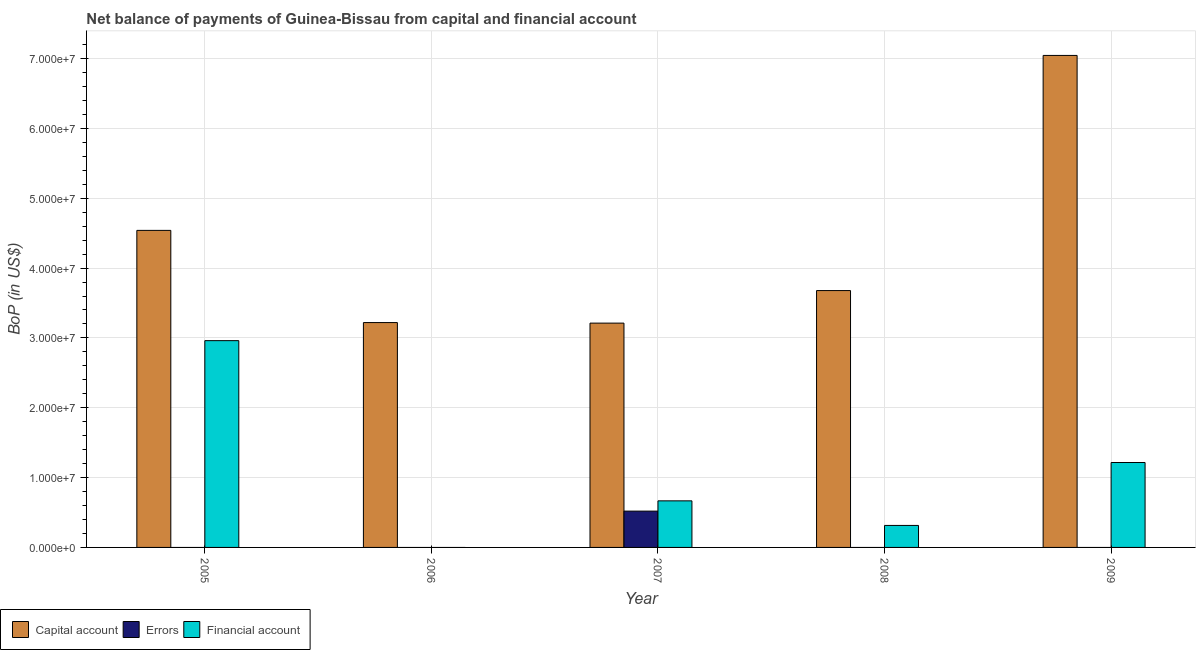How many different coloured bars are there?
Ensure brevity in your answer.  3. How many bars are there on the 1st tick from the right?
Provide a short and direct response. 2. In how many cases, is the number of bars for a given year not equal to the number of legend labels?
Keep it short and to the point. 4. What is the amount of financial account in 2005?
Your answer should be very brief. 2.96e+07. Across all years, what is the maximum amount of financial account?
Your answer should be compact. 2.96e+07. Across all years, what is the minimum amount of errors?
Provide a succinct answer. 0. In which year was the amount of errors maximum?
Your answer should be very brief. 2007. What is the total amount of financial account in the graph?
Your answer should be very brief. 5.16e+07. What is the difference between the amount of net capital account in 2006 and that in 2008?
Give a very brief answer. -4.58e+06. What is the difference between the amount of financial account in 2006 and the amount of net capital account in 2009?
Ensure brevity in your answer.  -1.22e+07. What is the average amount of net capital account per year?
Provide a succinct answer. 4.34e+07. In how many years, is the amount of net capital account greater than 24000000 US$?
Keep it short and to the point. 5. What is the ratio of the amount of financial account in 2005 to that in 2009?
Keep it short and to the point. 2.43. What is the difference between the highest and the second highest amount of net capital account?
Keep it short and to the point. 2.51e+07. What is the difference between the highest and the lowest amount of errors?
Ensure brevity in your answer.  5.20e+06. Is the sum of the amount of financial account in 2005 and 2009 greater than the maximum amount of errors across all years?
Provide a succinct answer. Yes. How many years are there in the graph?
Keep it short and to the point. 5. What is the difference between two consecutive major ticks on the Y-axis?
Provide a short and direct response. 1.00e+07. Where does the legend appear in the graph?
Your answer should be very brief. Bottom left. How are the legend labels stacked?
Your answer should be very brief. Horizontal. What is the title of the graph?
Your response must be concise. Net balance of payments of Guinea-Bissau from capital and financial account. What is the label or title of the Y-axis?
Provide a succinct answer. BoP (in US$). What is the BoP (in US$) in Capital account in 2005?
Provide a short and direct response. 4.54e+07. What is the BoP (in US$) of Errors in 2005?
Your answer should be very brief. 0. What is the BoP (in US$) in Financial account in 2005?
Provide a succinct answer. 2.96e+07. What is the BoP (in US$) of Capital account in 2006?
Offer a terse response. 3.22e+07. What is the BoP (in US$) in Errors in 2006?
Offer a terse response. 0. What is the BoP (in US$) in Capital account in 2007?
Ensure brevity in your answer.  3.21e+07. What is the BoP (in US$) of Errors in 2007?
Offer a terse response. 5.20e+06. What is the BoP (in US$) of Financial account in 2007?
Your answer should be compact. 6.67e+06. What is the BoP (in US$) of Capital account in 2008?
Provide a short and direct response. 3.68e+07. What is the BoP (in US$) in Financial account in 2008?
Your response must be concise. 3.15e+06. What is the BoP (in US$) of Capital account in 2009?
Provide a short and direct response. 7.05e+07. What is the BoP (in US$) in Financial account in 2009?
Offer a very short reply. 1.22e+07. Across all years, what is the maximum BoP (in US$) of Capital account?
Offer a very short reply. 7.05e+07. Across all years, what is the maximum BoP (in US$) in Errors?
Your answer should be very brief. 5.20e+06. Across all years, what is the maximum BoP (in US$) of Financial account?
Your answer should be very brief. 2.96e+07. Across all years, what is the minimum BoP (in US$) in Capital account?
Your answer should be very brief. 3.21e+07. Across all years, what is the minimum BoP (in US$) in Financial account?
Give a very brief answer. 0. What is the total BoP (in US$) in Capital account in the graph?
Keep it short and to the point. 2.17e+08. What is the total BoP (in US$) of Errors in the graph?
Your response must be concise. 5.20e+06. What is the total BoP (in US$) of Financial account in the graph?
Provide a succinct answer. 5.16e+07. What is the difference between the BoP (in US$) of Capital account in 2005 and that in 2006?
Your answer should be compact. 1.32e+07. What is the difference between the BoP (in US$) in Capital account in 2005 and that in 2007?
Your answer should be compact. 1.33e+07. What is the difference between the BoP (in US$) of Financial account in 2005 and that in 2007?
Give a very brief answer. 2.29e+07. What is the difference between the BoP (in US$) of Capital account in 2005 and that in 2008?
Provide a short and direct response. 8.62e+06. What is the difference between the BoP (in US$) in Financial account in 2005 and that in 2008?
Provide a short and direct response. 2.65e+07. What is the difference between the BoP (in US$) of Capital account in 2005 and that in 2009?
Make the answer very short. -2.51e+07. What is the difference between the BoP (in US$) in Financial account in 2005 and that in 2009?
Ensure brevity in your answer.  1.74e+07. What is the difference between the BoP (in US$) of Capital account in 2006 and that in 2007?
Your response must be concise. 7.78e+04. What is the difference between the BoP (in US$) of Capital account in 2006 and that in 2008?
Your answer should be compact. -4.58e+06. What is the difference between the BoP (in US$) of Capital account in 2006 and that in 2009?
Your answer should be compact. -3.83e+07. What is the difference between the BoP (in US$) of Capital account in 2007 and that in 2008?
Your response must be concise. -4.66e+06. What is the difference between the BoP (in US$) in Financial account in 2007 and that in 2008?
Offer a terse response. 3.52e+06. What is the difference between the BoP (in US$) in Capital account in 2007 and that in 2009?
Keep it short and to the point. -3.83e+07. What is the difference between the BoP (in US$) of Financial account in 2007 and that in 2009?
Make the answer very short. -5.49e+06. What is the difference between the BoP (in US$) in Capital account in 2008 and that in 2009?
Offer a very short reply. -3.37e+07. What is the difference between the BoP (in US$) in Financial account in 2008 and that in 2009?
Ensure brevity in your answer.  -9.01e+06. What is the difference between the BoP (in US$) in Capital account in 2005 and the BoP (in US$) in Errors in 2007?
Offer a terse response. 4.02e+07. What is the difference between the BoP (in US$) of Capital account in 2005 and the BoP (in US$) of Financial account in 2007?
Keep it short and to the point. 3.87e+07. What is the difference between the BoP (in US$) of Capital account in 2005 and the BoP (in US$) of Financial account in 2008?
Offer a very short reply. 4.22e+07. What is the difference between the BoP (in US$) in Capital account in 2005 and the BoP (in US$) in Financial account in 2009?
Your answer should be very brief. 3.32e+07. What is the difference between the BoP (in US$) in Capital account in 2006 and the BoP (in US$) in Errors in 2007?
Your answer should be very brief. 2.70e+07. What is the difference between the BoP (in US$) of Capital account in 2006 and the BoP (in US$) of Financial account in 2007?
Your response must be concise. 2.55e+07. What is the difference between the BoP (in US$) of Capital account in 2006 and the BoP (in US$) of Financial account in 2008?
Your answer should be very brief. 2.90e+07. What is the difference between the BoP (in US$) of Capital account in 2006 and the BoP (in US$) of Financial account in 2009?
Ensure brevity in your answer.  2.00e+07. What is the difference between the BoP (in US$) in Capital account in 2007 and the BoP (in US$) in Financial account in 2008?
Your answer should be compact. 2.90e+07. What is the difference between the BoP (in US$) in Errors in 2007 and the BoP (in US$) in Financial account in 2008?
Offer a terse response. 2.05e+06. What is the difference between the BoP (in US$) of Capital account in 2007 and the BoP (in US$) of Financial account in 2009?
Give a very brief answer. 2.00e+07. What is the difference between the BoP (in US$) in Errors in 2007 and the BoP (in US$) in Financial account in 2009?
Keep it short and to the point. -6.96e+06. What is the difference between the BoP (in US$) of Capital account in 2008 and the BoP (in US$) of Financial account in 2009?
Keep it short and to the point. 2.46e+07. What is the average BoP (in US$) in Capital account per year?
Ensure brevity in your answer.  4.34e+07. What is the average BoP (in US$) in Errors per year?
Your answer should be very brief. 1.04e+06. What is the average BoP (in US$) of Financial account per year?
Offer a terse response. 1.03e+07. In the year 2005, what is the difference between the BoP (in US$) of Capital account and BoP (in US$) of Financial account?
Give a very brief answer. 1.58e+07. In the year 2007, what is the difference between the BoP (in US$) of Capital account and BoP (in US$) of Errors?
Your response must be concise. 2.69e+07. In the year 2007, what is the difference between the BoP (in US$) in Capital account and BoP (in US$) in Financial account?
Your response must be concise. 2.55e+07. In the year 2007, what is the difference between the BoP (in US$) of Errors and BoP (in US$) of Financial account?
Provide a succinct answer. -1.47e+06. In the year 2008, what is the difference between the BoP (in US$) in Capital account and BoP (in US$) in Financial account?
Keep it short and to the point. 3.36e+07. In the year 2009, what is the difference between the BoP (in US$) of Capital account and BoP (in US$) of Financial account?
Ensure brevity in your answer.  5.83e+07. What is the ratio of the BoP (in US$) of Capital account in 2005 to that in 2006?
Your answer should be very brief. 1.41. What is the ratio of the BoP (in US$) in Capital account in 2005 to that in 2007?
Provide a succinct answer. 1.41. What is the ratio of the BoP (in US$) in Financial account in 2005 to that in 2007?
Keep it short and to the point. 4.44. What is the ratio of the BoP (in US$) in Capital account in 2005 to that in 2008?
Offer a terse response. 1.23. What is the ratio of the BoP (in US$) of Financial account in 2005 to that in 2008?
Keep it short and to the point. 9.4. What is the ratio of the BoP (in US$) of Capital account in 2005 to that in 2009?
Provide a short and direct response. 0.64. What is the ratio of the BoP (in US$) of Financial account in 2005 to that in 2009?
Provide a short and direct response. 2.44. What is the ratio of the BoP (in US$) of Capital account in 2006 to that in 2008?
Provide a succinct answer. 0.88. What is the ratio of the BoP (in US$) in Capital account in 2006 to that in 2009?
Provide a succinct answer. 0.46. What is the ratio of the BoP (in US$) of Capital account in 2007 to that in 2008?
Your answer should be very brief. 0.87. What is the ratio of the BoP (in US$) of Financial account in 2007 to that in 2008?
Offer a very short reply. 2.12. What is the ratio of the BoP (in US$) in Capital account in 2007 to that in 2009?
Ensure brevity in your answer.  0.46. What is the ratio of the BoP (in US$) in Financial account in 2007 to that in 2009?
Provide a succinct answer. 0.55. What is the ratio of the BoP (in US$) in Capital account in 2008 to that in 2009?
Offer a very short reply. 0.52. What is the ratio of the BoP (in US$) of Financial account in 2008 to that in 2009?
Ensure brevity in your answer.  0.26. What is the difference between the highest and the second highest BoP (in US$) in Capital account?
Your answer should be very brief. 2.51e+07. What is the difference between the highest and the second highest BoP (in US$) of Financial account?
Provide a short and direct response. 1.74e+07. What is the difference between the highest and the lowest BoP (in US$) of Capital account?
Provide a short and direct response. 3.83e+07. What is the difference between the highest and the lowest BoP (in US$) in Errors?
Provide a succinct answer. 5.20e+06. What is the difference between the highest and the lowest BoP (in US$) in Financial account?
Make the answer very short. 2.96e+07. 